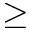Convert formula to latex. <formula><loc_0><loc_0><loc_500><loc_500>\geq</formula> 